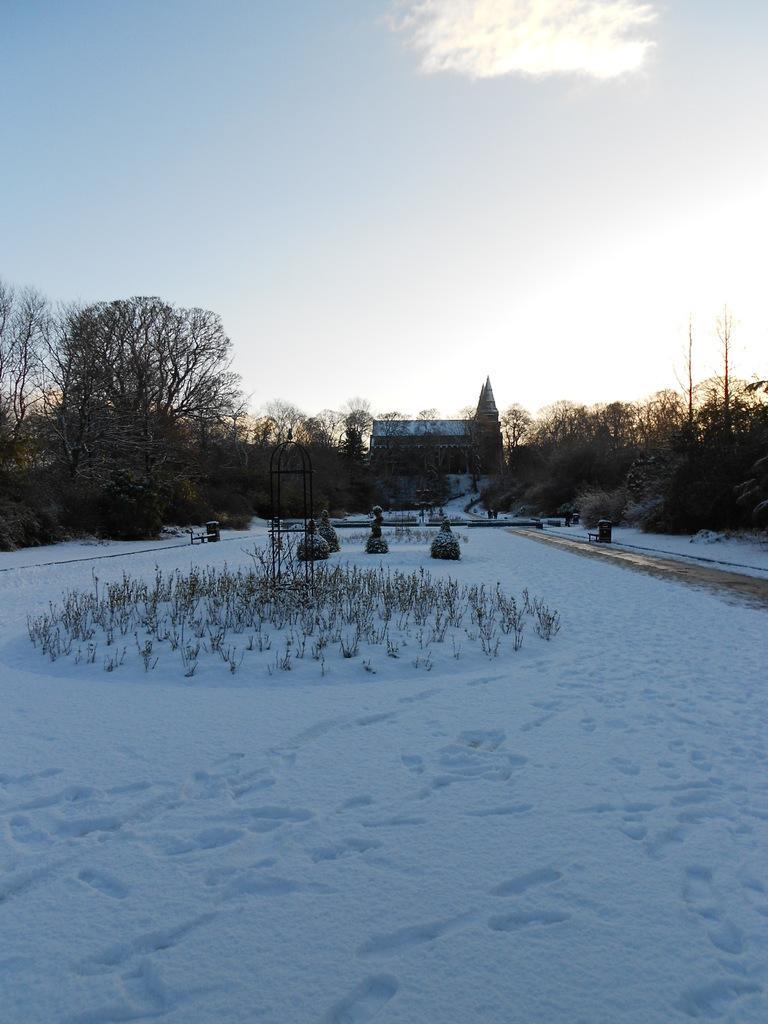In one or two sentences, can you explain what this image depicts? In the foreground of the picture there are plants and snow. In the center of the picture there are trees, plants and a house. At the top it is sky. 